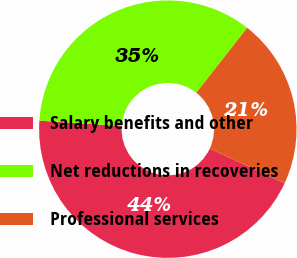<chart> <loc_0><loc_0><loc_500><loc_500><pie_chart><fcel>Salary benefits and other<fcel>Net reductions in recoveries<fcel>Professional services<nl><fcel>44.16%<fcel>34.52%<fcel>21.32%<nl></chart> 